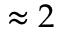<formula> <loc_0><loc_0><loc_500><loc_500>\approx 2</formula> 